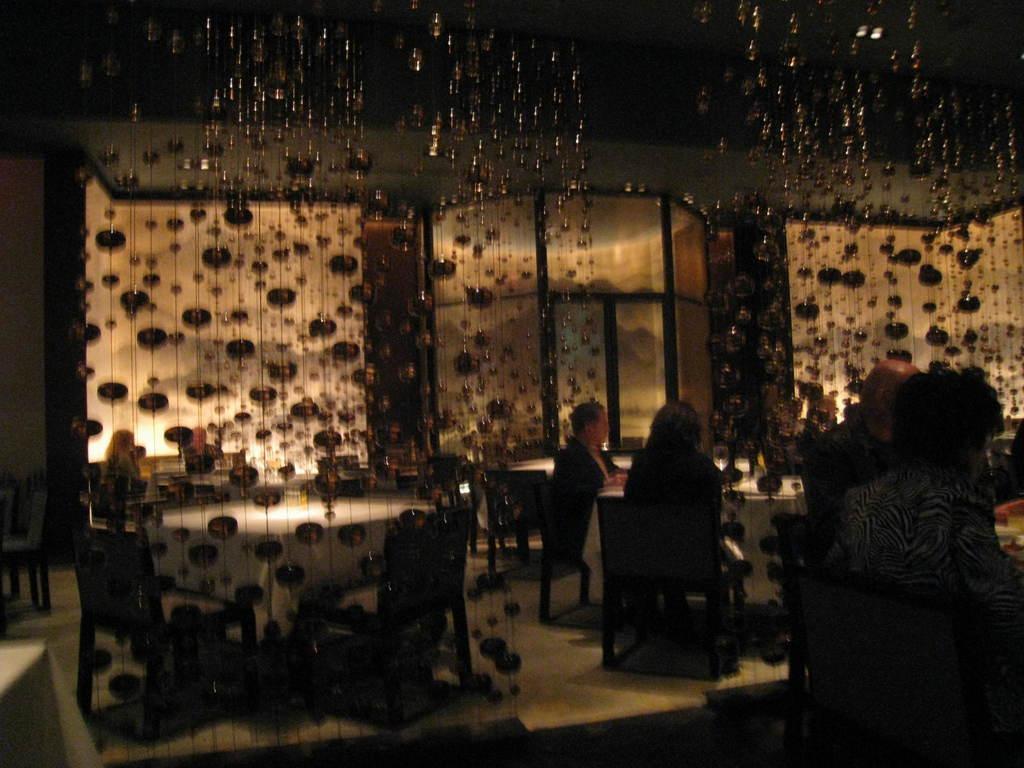Can you describe this image briefly? This is an image of the restaurant where we can see tables with chairs around, also there some people sitting in some chairs and we can see some glass walls and bead hanging curtains. 